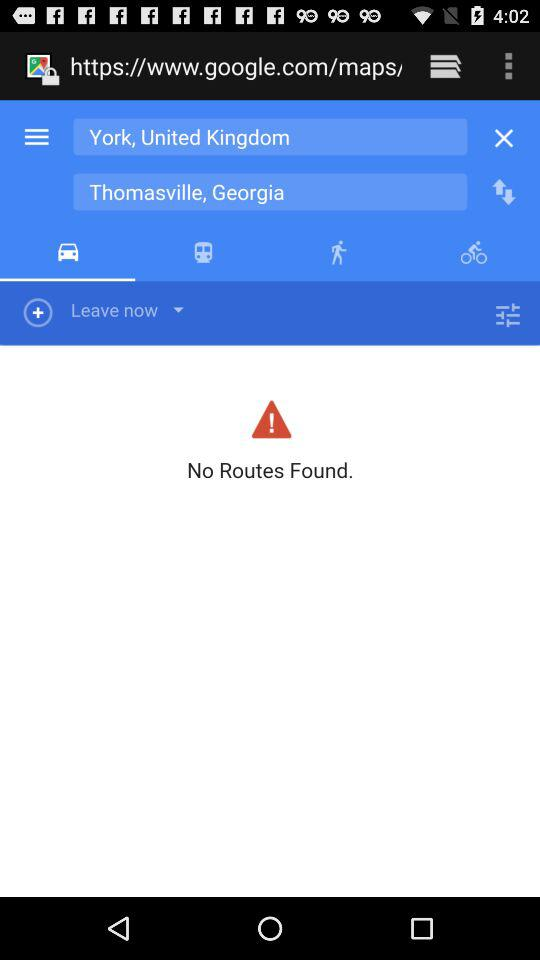What is the departure location? The departure location is "York, United Kingdom". 